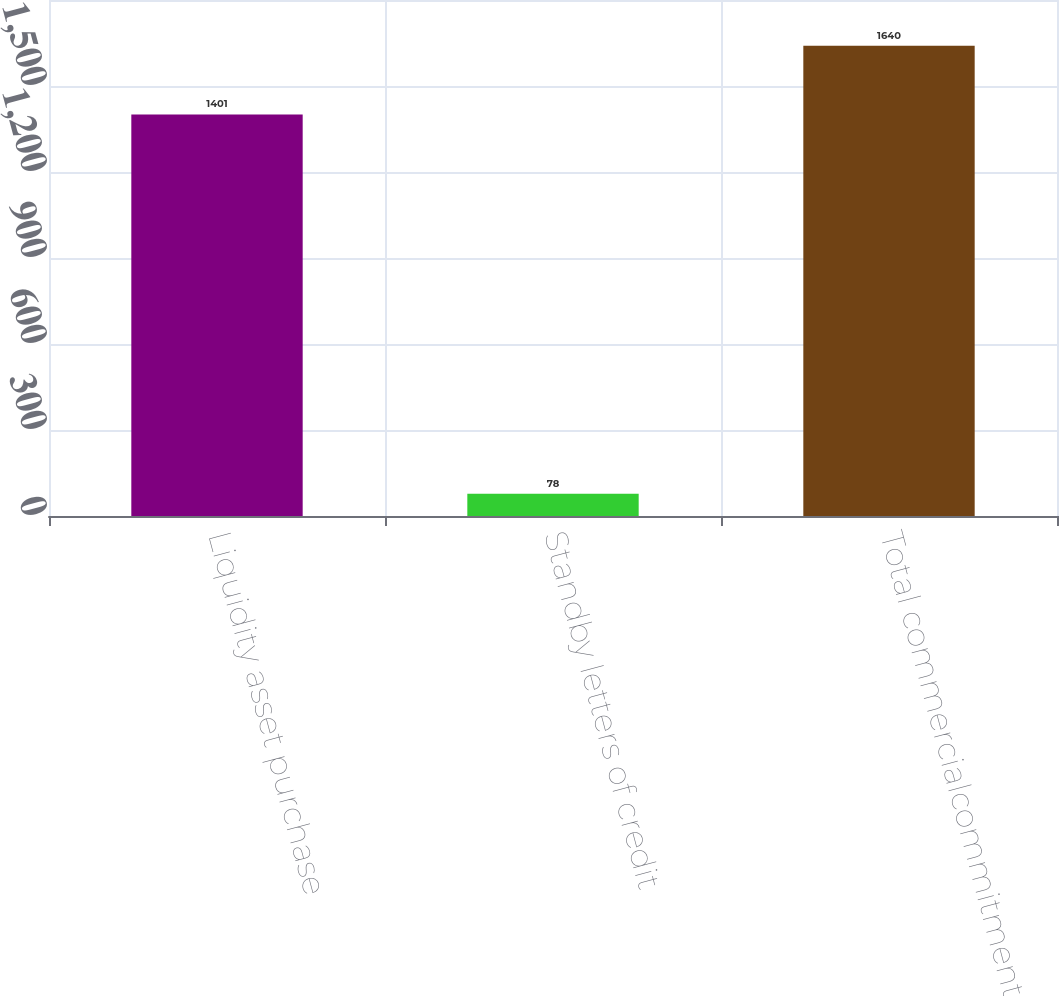Convert chart. <chart><loc_0><loc_0><loc_500><loc_500><bar_chart><fcel>Liquidity asset purchase<fcel>Standby letters of credit<fcel>Total commercialcommitments<nl><fcel>1401<fcel>78<fcel>1640<nl></chart> 